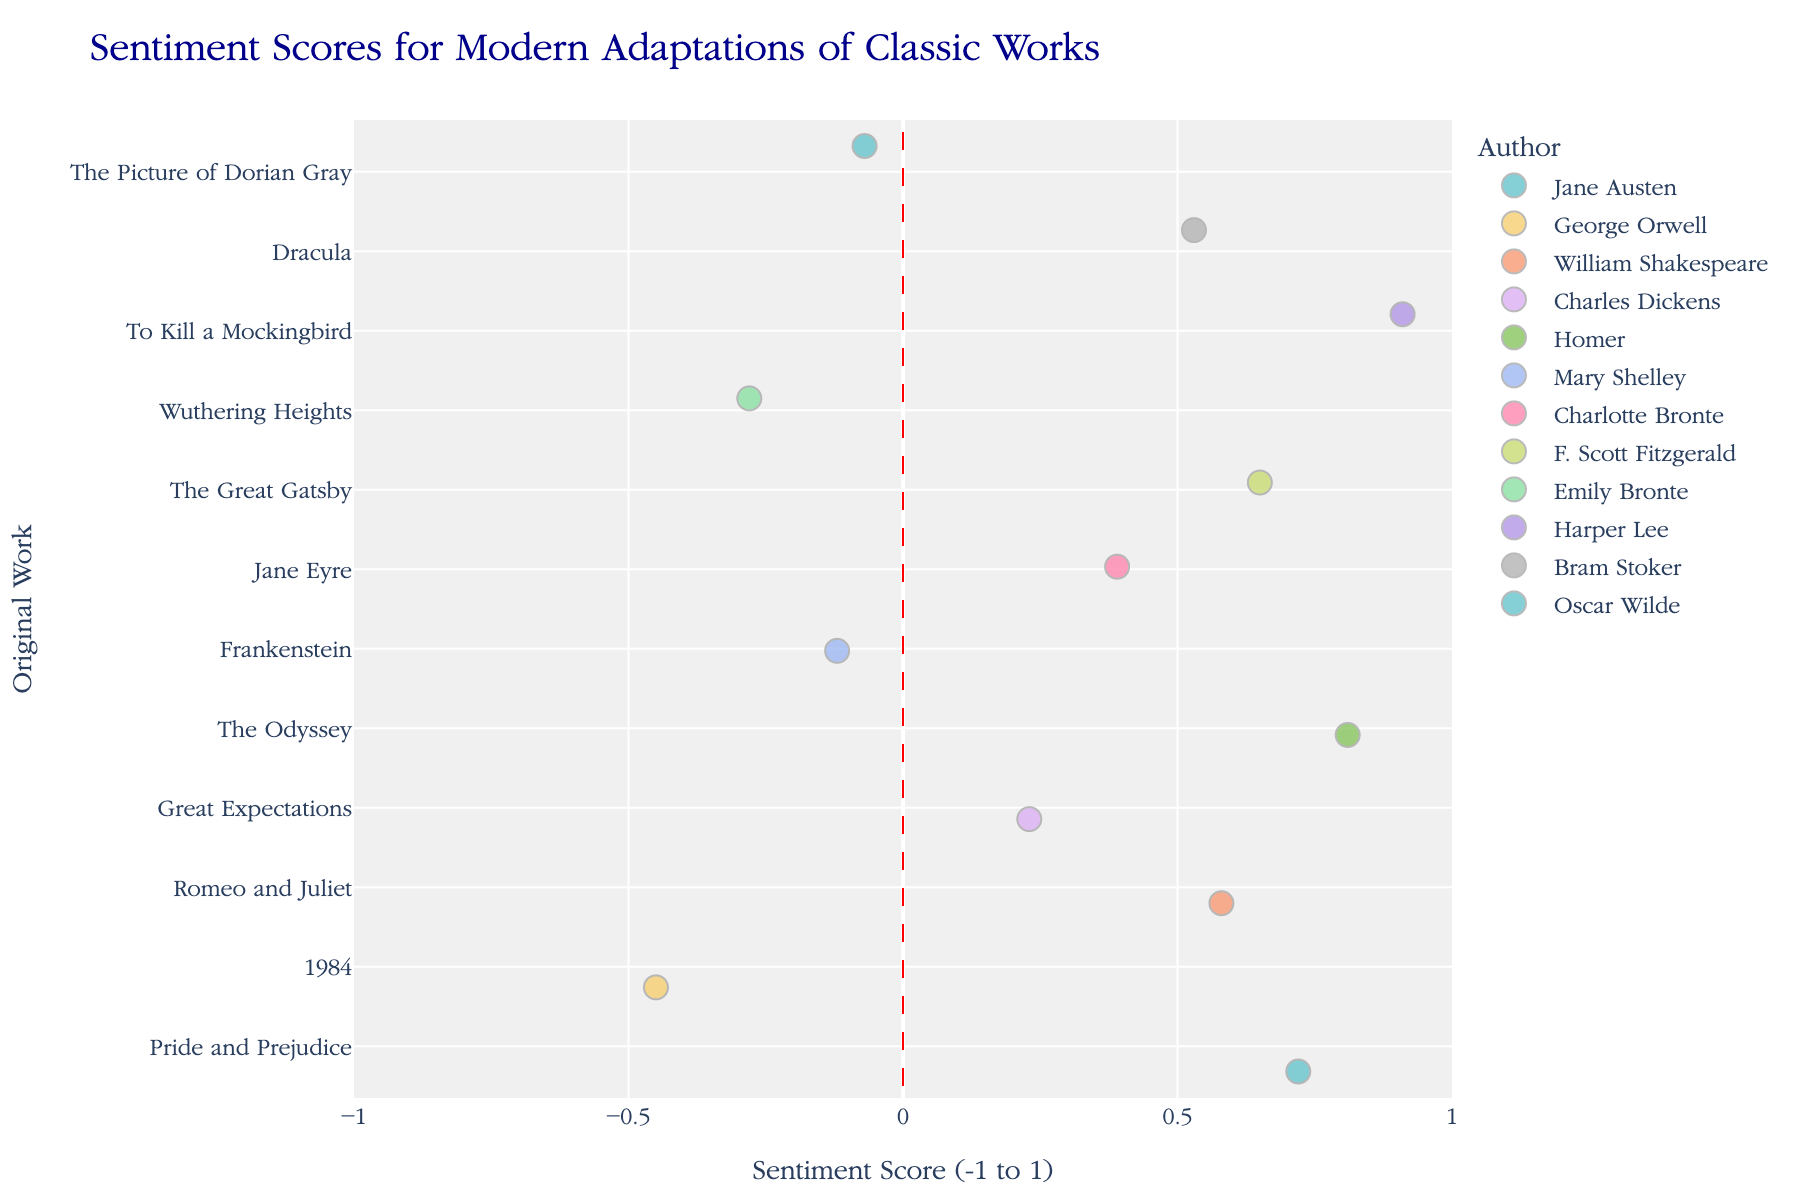How many original works have a sentiment score greater than 0.5? To answer this question, count the data points with sentiment scores greater than 0.5 on the x-axis. The values 0.72, 0.58, 0.81, 0.65, 0.91 all meet this criterion.
Answer: 5 Which adaptation has the lowest sentiment score? Examine the data points to identify the adaptation with the lowest sentiment score on the x-axis. "The Handmaid's Tale (TV series)" for "1984" has the lowest score of -0.45.
Answer: The Handmaid's Tale (TV series) What is the average sentiment score of all adaptations? Sum all the sentiment scores and divide by the number of adaptations. Sentiment scores: 0.72, -0.45, 0.58, 0.23, 0.81, -0.12, 0.39, 0.65, -0.28, 0.91, 0.53, -0.07. Sum is 3.90 and there are 12 adaptations. Average = 3.90 / 12.
Answer: 0.325 Which author has the highest average sentiment score for their adaptations? Group the data by author and calculate the average sentiment score for each. Compare these averages to find the highest one. Homer's "The Odyssey" adaptation "Circe (Madeline Miller)" has the highest sentiment score of 0.81 as a single author-adaptation with the highest score.
Answer: Homer What is the difference between the sentiment scores of "Pride and Prejudice" and "1984"? Identify the sentiment scores for both works. "Pride and Prejudice" has 0.72 and "1984" has -0.45. Calculate the difference: 0.72 - (-0.45) = 0.72 + 0.45 = 1.17.
Answer: 1.17 Are most sentiment scores positive or negative? Count the number of sentiment scores greater than 0 and those less than 0. There are 8 positive scores and 4 negative scores.
Answer: Positive What is the median sentiment score of the adaptations? Order the sentiment scores and find the middle value(s). Ordered scores: -0.45, -0.28, -0.12, -0.07, 0.23, 0.39, 0.53, 0.58, 0.65, 0.72, 0.81, 0.91. The middle values are 0.39 and 0.53. Median = (0.39 + 0.53) / 2.
Answer: 0.46 